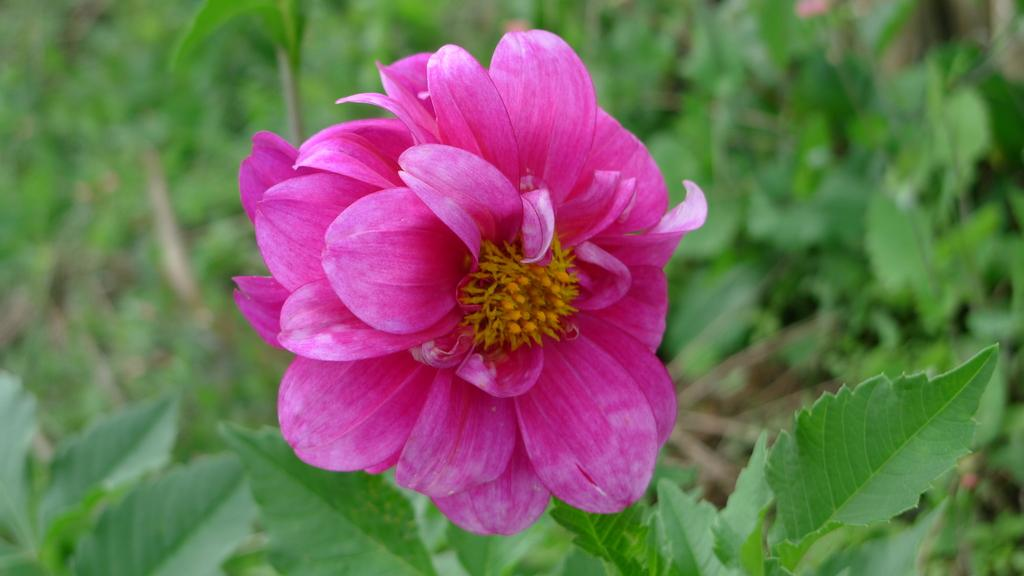What is the main subject of the image? There is a pink color flower in the middle of the image. What can be seen surrounding the flower? There are green leaves in the image. How does the flower increase in size in the image? The flower does not increase in size in the image; it is a static representation of the flower. 